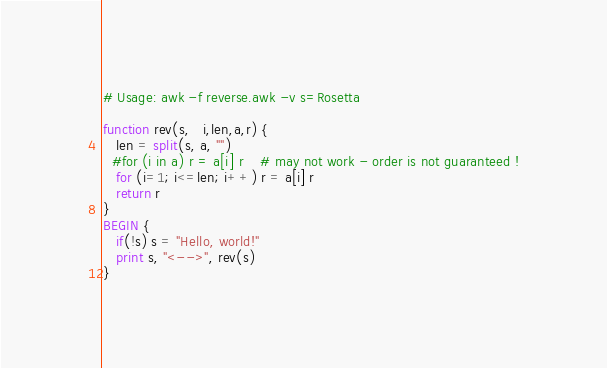<code> <loc_0><loc_0><loc_500><loc_500><_Awk_># Usage: awk -f reverse.awk -v s=Rosetta

function rev(s,   i,len,a,r) {
   len = split(s, a, "")
  #for (i in a) r = a[i] r	# may not work - order is not guaranteed !
   for (i=1; i<=len; i++) r = a[i] r
   return r
}
BEGIN {
   if(!s) s = "Hello, world!"
   print s, "<-->", rev(s)
}
</code> 